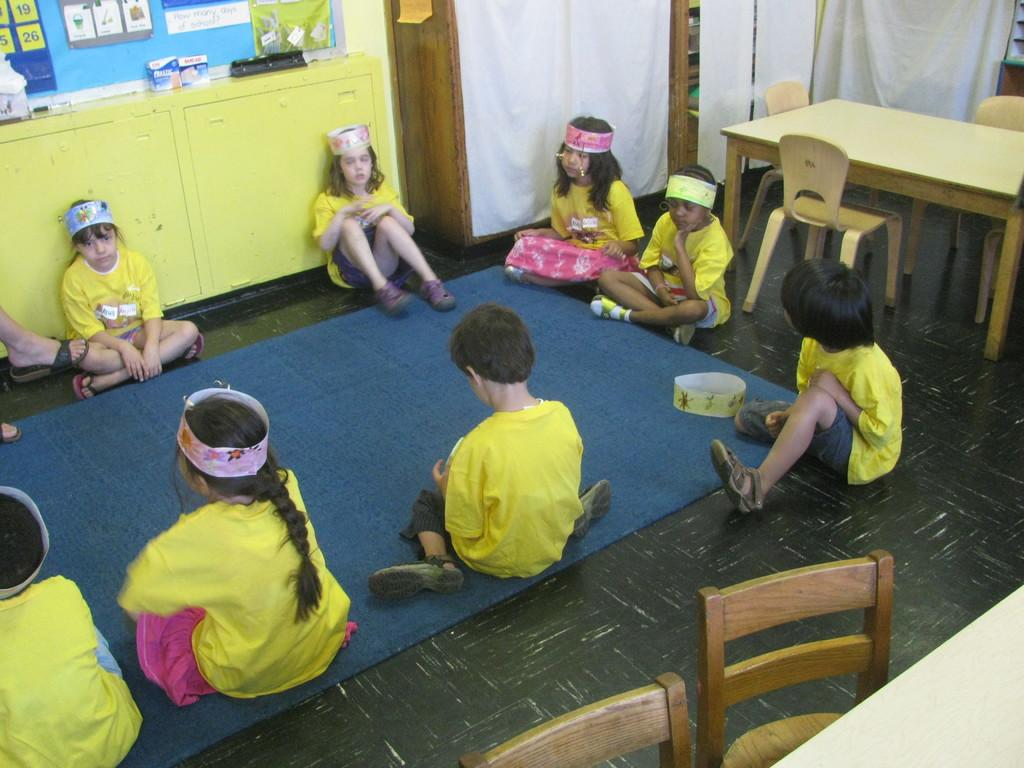What is the main subject of the image? The main subject of the image is a group of children. What are the children doing in the image? The children are sitting on the floor. Can you describe any accessories the children are wearing? Some of the children are wearing hair bands. What can be seen in the background of the image? In the background of the image, there are cupboards, a poster, tables, chairs, and curtains. What type of silverware is visible on the tables in the image? There is no silverware visible on the tables in the image. How many books can be seen on the floor with the children? There are no books visible on the floor with the children in the image. 